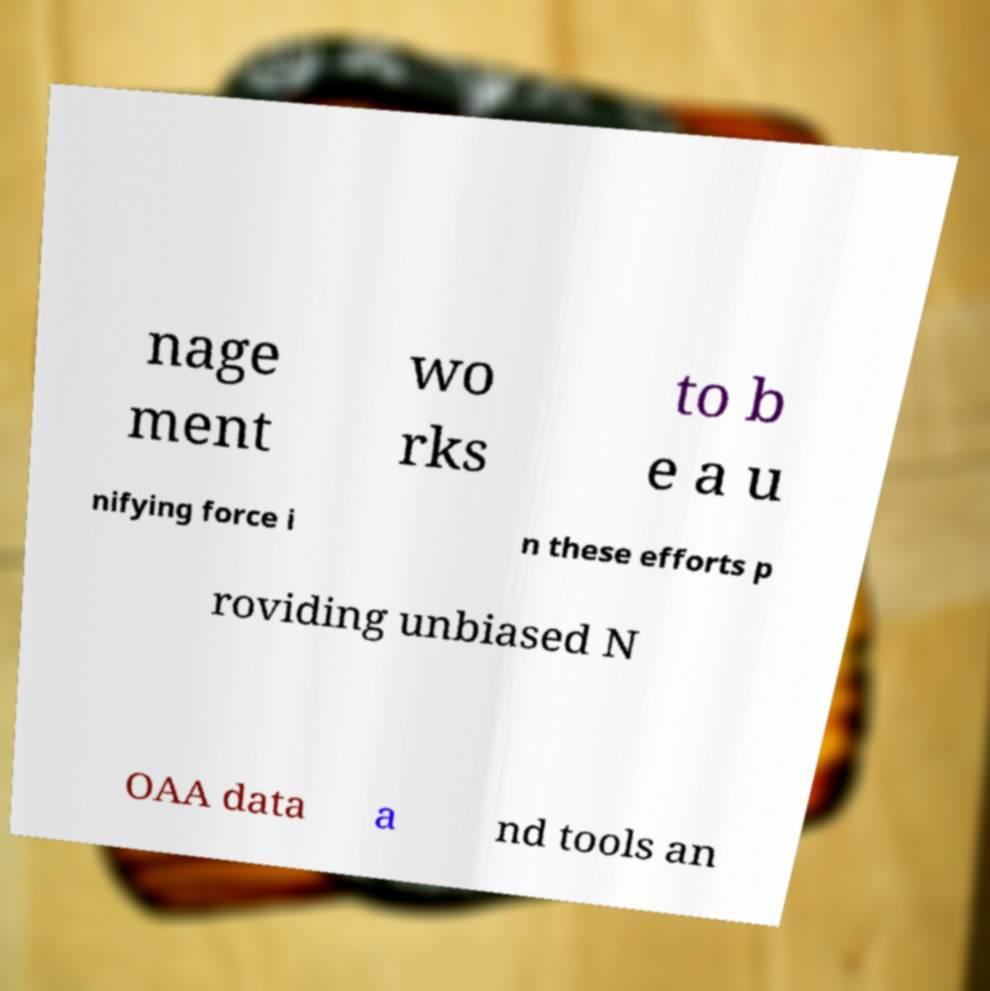Please read and relay the text visible in this image. What does it say? nage ment wo rks to b e a u nifying force i n these efforts p roviding unbiased N OAA data a nd tools an 